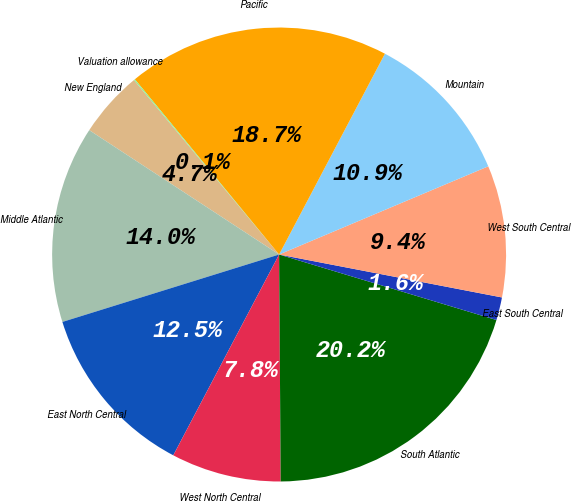Convert chart. <chart><loc_0><loc_0><loc_500><loc_500><pie_chart><fcel>New England<fcel>Middle Atlantic<fcel>East North Central<fcel>West North Central<fcel>South Atlantic<fcel>East South Central<fcel>West South Central<fcel>Mountain<fcel>Pacific<fcel>Valuation allowance<nl><fcel>4.73%<fcel>14.03%<fcel>12.48%<fcel>7.83%<fcel>20.23%<fcel>1.63%<fcel>9.38%<fcel>10.93%<fcel>18.68%<fcel>0.08%<nl></chart> 